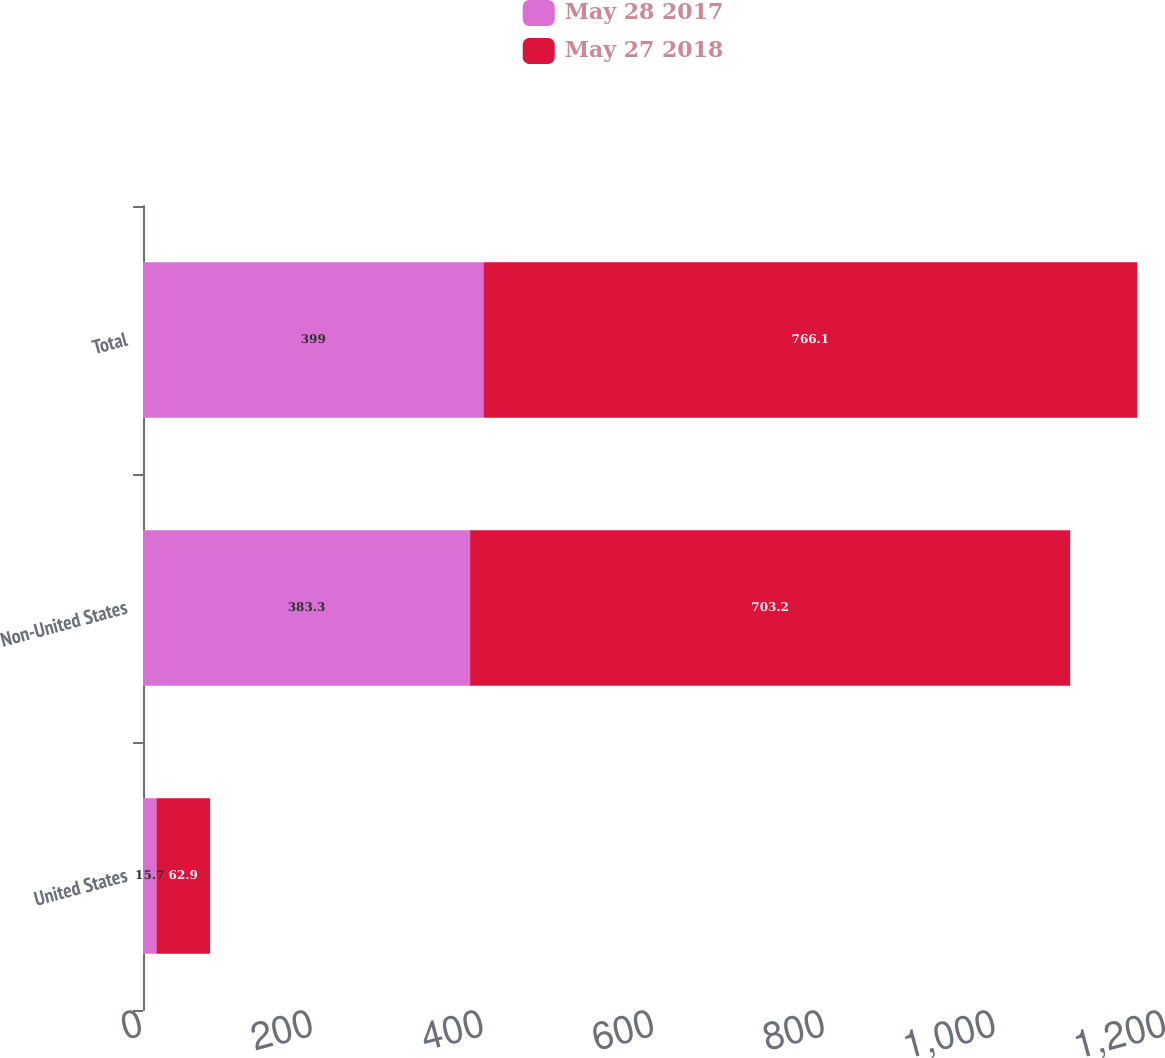Convert chart. <chart><loc_0><loc_0><loc_500><loc_500><stacked_bar_chart><ecel><fcel>United States<fcel>Non-United States<fcel>Total<nl><fcel>May 28 2017<fcel>15.7<fcel>383.3<fcel>399<nl><fcel>May 27 2018<fcel>62.9<fcel>703.2<fcel>766.1<nl></chart> 